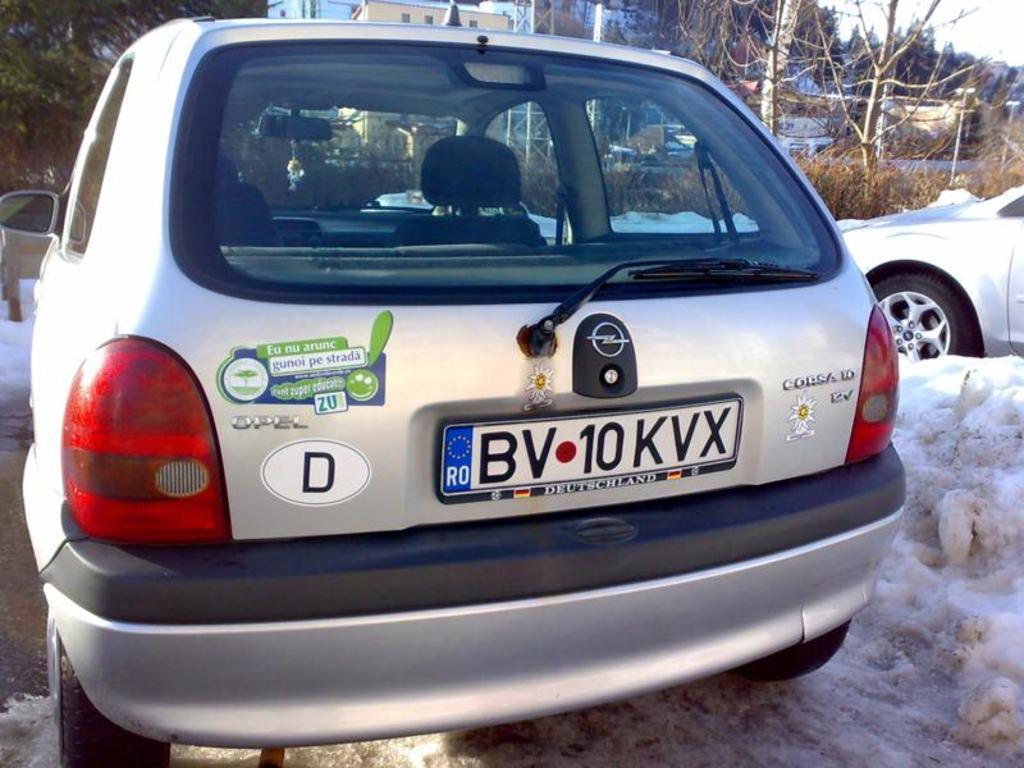What's the license plate number of this automobile?
Your response must be concise. Bv 10 kvx. What model is this car?
Provide a short and direct response. Corsa 10. 